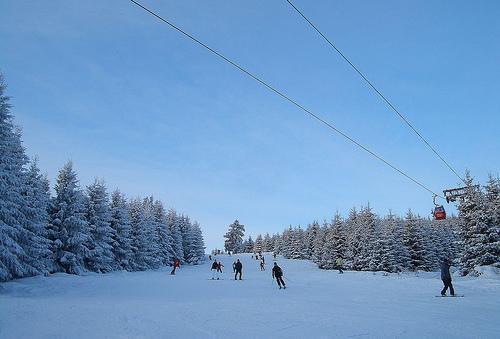How many cables are seen?
Give a very brief answer. 2. 